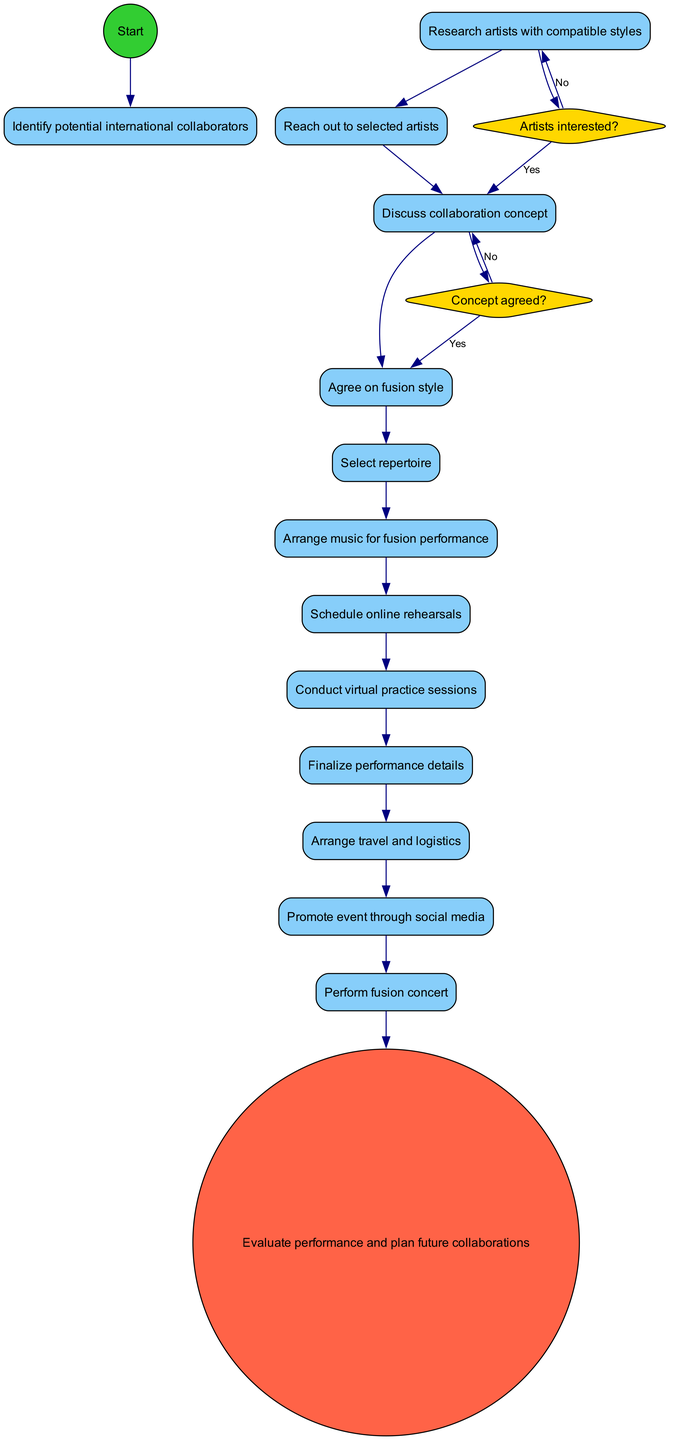What is the starting point of the diagram? The starting point, indicated in the diagram, is explicitly labeled as "Identify potential international collaborators."
Answer: Identify potential international collaborators How many activities are listed in the diagram? The diagram includes a total of twelve activities that are defined in the provided list.
Answer: 12 What happens if the artists are not interested? According to the decision node "Artists interested?", if the answer is no, it leads back to the activity "Research artists with compatible styles."
Answer: Research artists with compatible styles What is the final stage in the diagram? The final stage, or end node, of the activity diagram is clearly labeled as "Evaluate performance and plan future collaborations."
Answer: Evaluate performance and plan future collaborations What is the condition that needs to be met to agree on the fusion style? The condition that must be satisfied to move to the activity "Agree on fusion style" is that the concept must be agreed upon.
Answer: Concept agreed What is the relationship between "Schedule online rehearsals" and "Conduct virtual practice sessions"? The diagram shows that "Schedule online rehearsals" directly leads to "Conduct virtual practice sessions," indicating a sequential flow from one to the other.
Answer: Sequential flow If the concept is not agreed upon, what is the next step? If the concept is not agreed upon, it loops back to the activity "Discuss collaboration concept" according to the diagram's flow.
Answer: Discuss collaboration concept What activity follows "Agree on fusion style"? The activity that follows "Agree on fusion style" in the sequence is "Select repertoire."
Answer: Select repertoire What condition leads to the decision on whether artists are interested? The starting activity is "Reach out to selected artists," which leads to the decision about whether the artists are interested.
Answer: Reach out to selected artists 